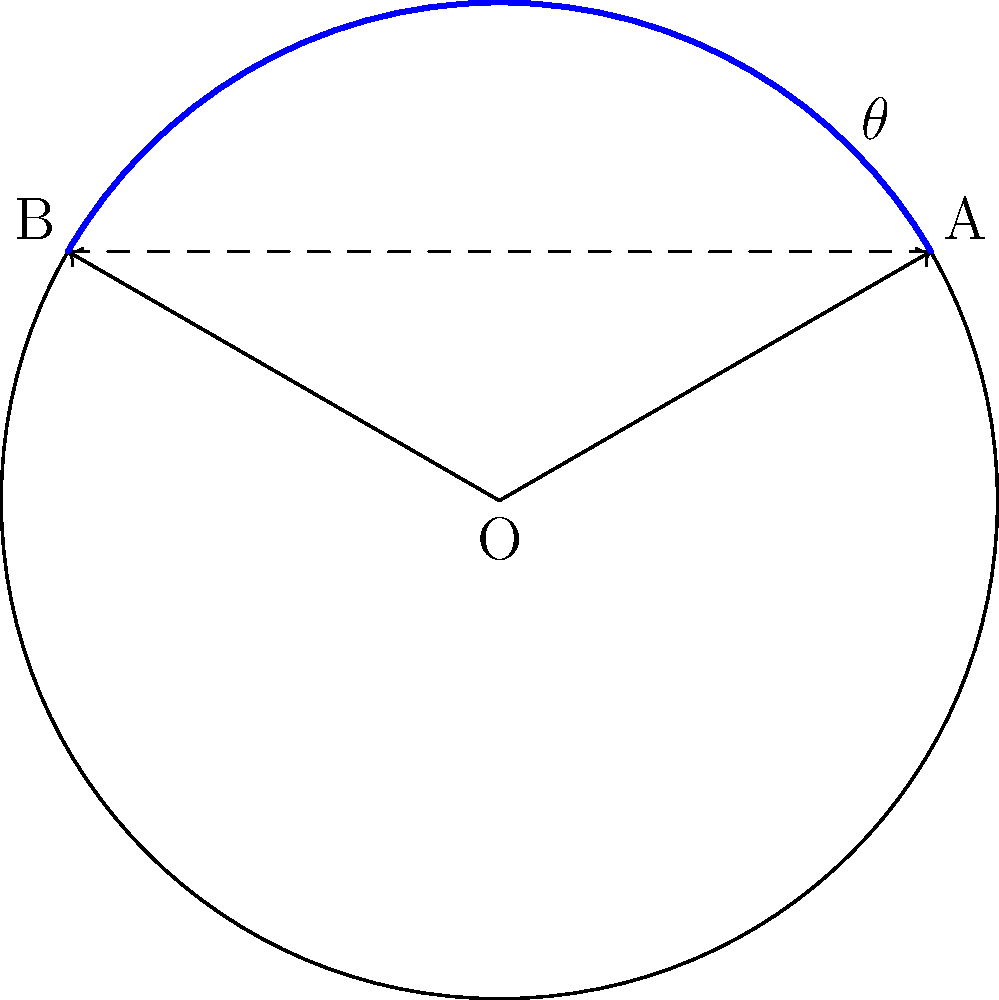In a circular airport with a radius of 100 meters, a new baggage conveyor belt needs to be installed between two points A and B on the perimeter. Point A is located at an angle of 30° from the positive x-axis, and point B is at 150°. Calculate the length of the conveyor belt if it's installed as a straight line between A and B, rounded to the nearest meter. To solve this problem, we'll use polar coordinates and the law of cosines. Here's the step-by-step solution:

1) First, we need to find the angle between points A and B:
   $\theta = 150° - 30° = 120°$

2) We can use the law of cosines to find the length of the chord AB:
   $AB^2 = OA^2 + OB^2 - 2(OA)(OB)\cos(\theta)$

   Where OA and OB are both equal to the radius (100 meters).

3) Substituting the values:
   $AB^2 = 100^2 + 100^2 - 2(100)(100)\cos(120°)$

4) Simplify:
   $AB^2 = 10000 + 10000 - 20000\cos(120°)$
   $AB^2 = 20000 - 20000(-0.5)$  (since $\cos(120°) = -0.5$)
   $AB^2 = 20000 + 10000 = 30000$

5) Take the square root of both sides:
   $AB = \sqrt{30000} \approx 173.2$ meters

6) Rounding to the nearest meter:
   $AB \approx 173$ meters
Answer: 173 meters 